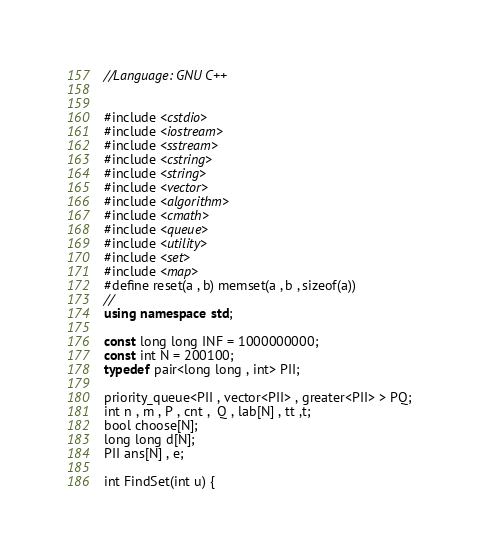Convert code to text. <code><loc_0><loc_0><loc_500><loc_500><_C++_>//Language: GNU C++


#include <cstdio>
#include <iostream>
#include <sstream>
#include <cstring>
#include <string>
#include <vector>
#include <algorithm>
#include <cmath>
#include <queue>
#include <utility>
#include <set>
#include <map>
#define reset(a , b) memset(a , b , sizeof(a))
//
using namespace std;

const long long INF = 1000000000;
const int N = 200100;
typedef pair<long long , int> PII;

priority_queue<PII , vector<PII> , greater<PII> > PQ;
int n , m , P , cnt ,  Q , lab[N] , tt ,t;
bool choose[N];
long long d[N];
PII ans[N] , e;

int FindSet(int u) {</code> 